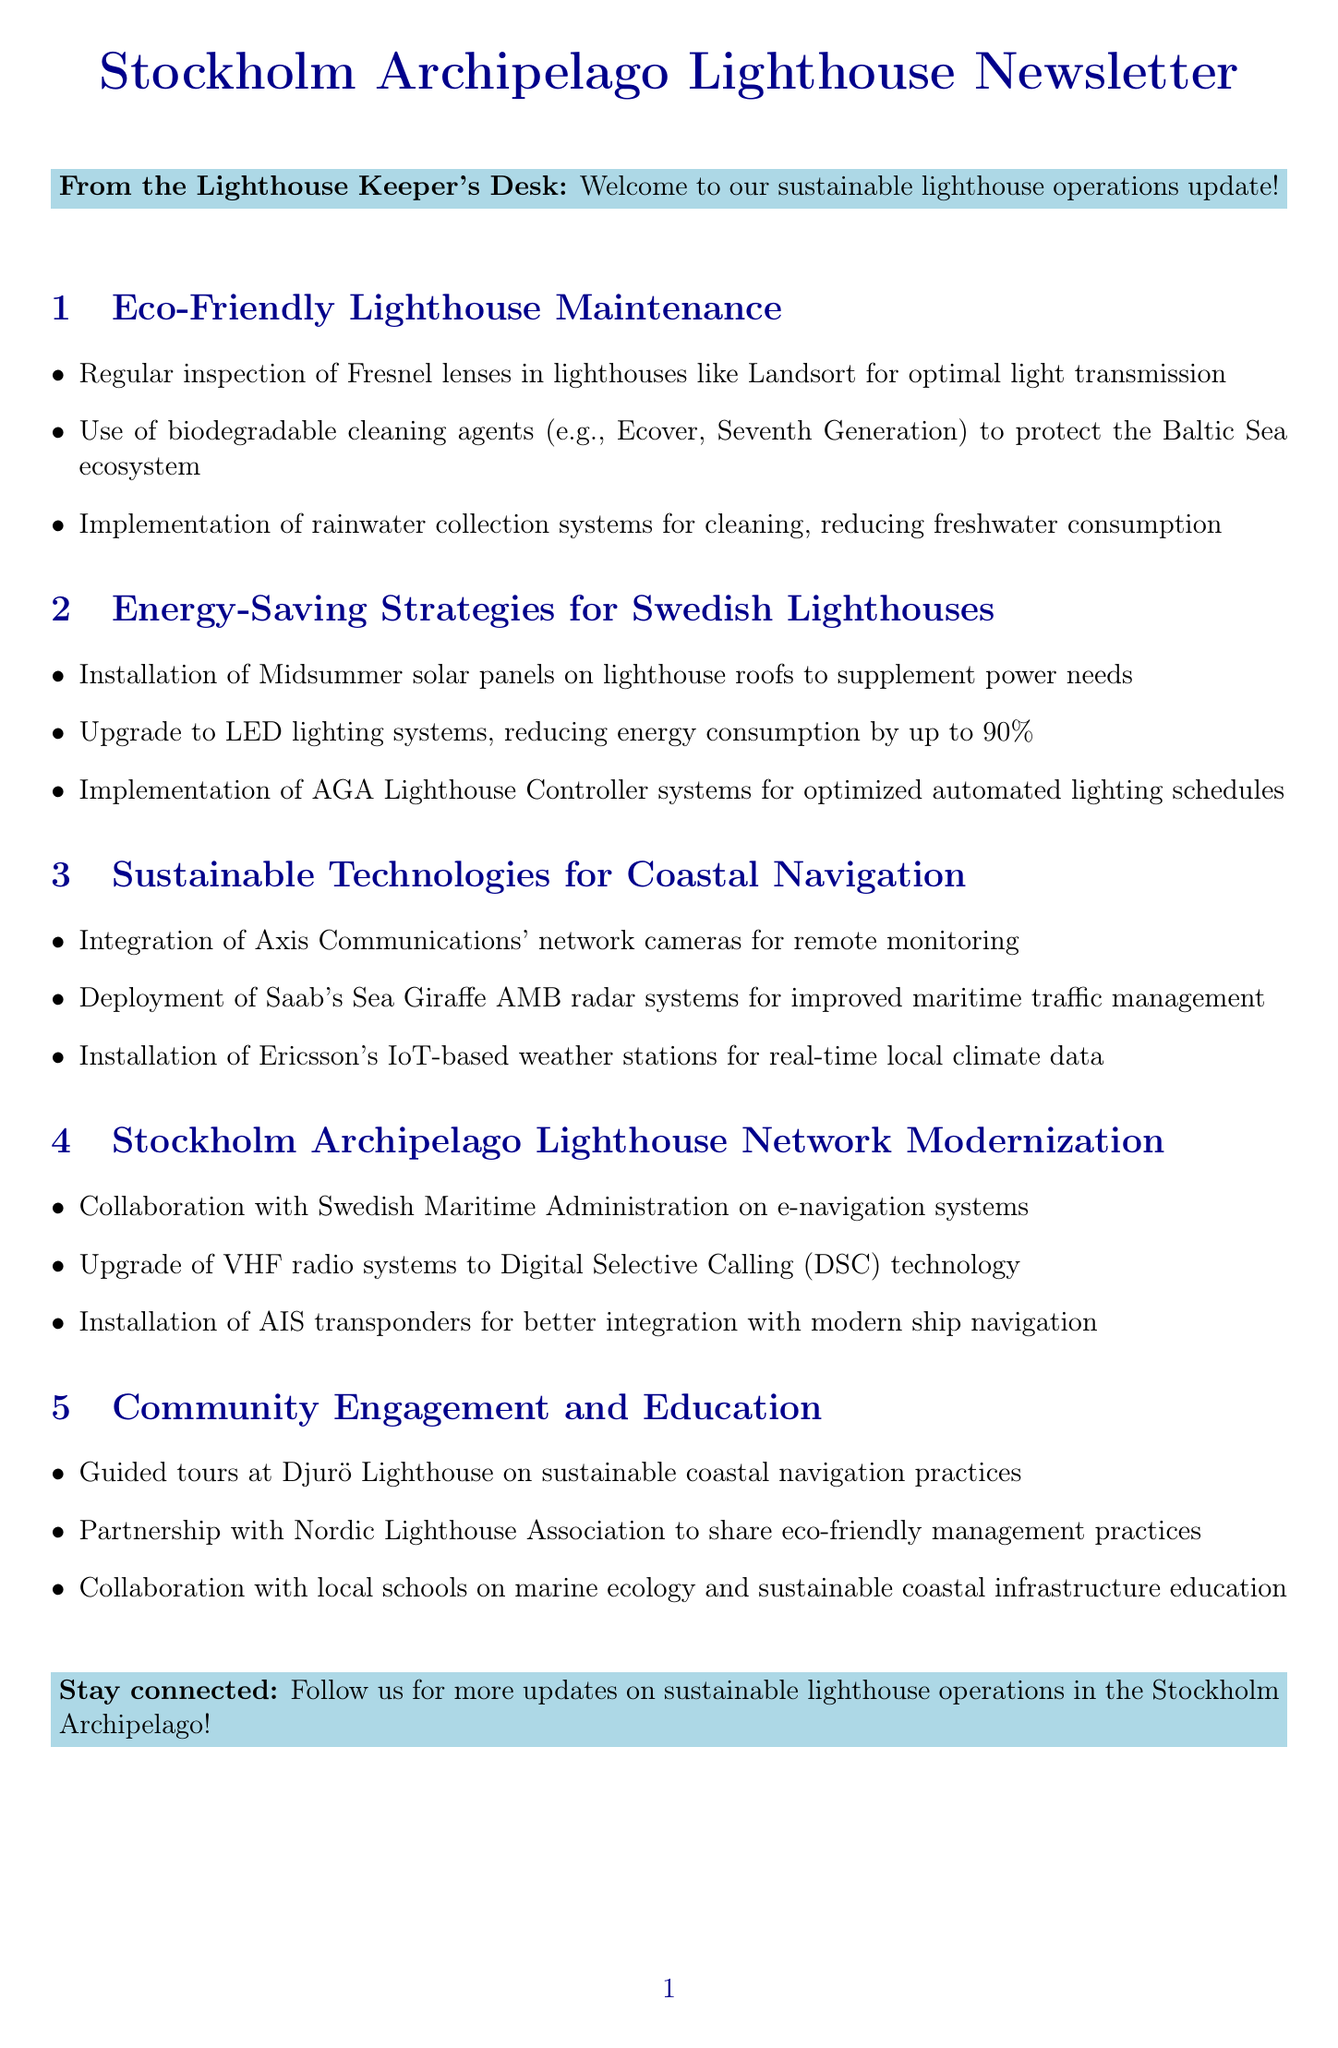What are the biodegradable cleaning agents mentioned? The newsletter lists Ecover and Seventh Generation as biodegradable cleaning agents used for lens and tower maintenance.
Answer: Ecover, Seventh Generation What technology is used for remote monitoring of lighthouse conditions? The document mentions the integration of Axis Communications' network cameras for remote monitoring purposes.
Answer: Axis Communications' network cameras How much can LED lighting systems reduce energy consumption? The newsletter states that LED lighting systems can reduce energy consumption by up to 90% compared to traditional incandescent bulbs.
Answer: 90% What is the purpose of implementing automated lighting schedules? The automated lighting schedules using AGA Lighthouse Controller systems optimize operation hours based on daylight conditions in the archipelago.
Answer: Optimize operation hours Which lighthouse is involved in guided tours for education? The document indicates that guided tours are organized at Djurö Lighthouse to educate visitors.
Answer: Djurö Lighthouse What system is being upgraded to Digital Selective Calling (DSC)? The newsletter discusses the upgrade of VHF radio systems to Digital Selective Calling (DSC) technology.
Answer: VHF radio systems How do rainwater collection systems contribute to maintenance? Rainwater collection systems help reduce freshwater consumption for cleaning purposes in remote lighthouse locations.
Answer: Reduce freshwater consumption Who collaborates with the Nordic Lighthouse Association? The newsletter mentions partnerships with the Nordic Lighthouse Association to share best practices in eco-friendly lighthouse management.
Answer: The newsletter's organization 